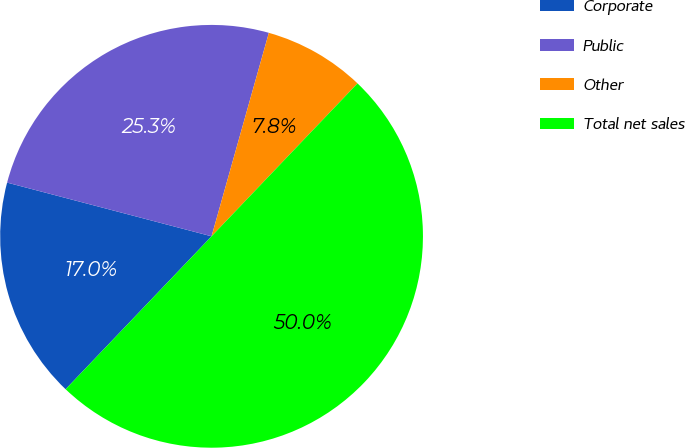Convert chart to OTSL. <chart><loc_0><loc_0><loc_500><loc_500><pie_chart><fcel>Corporate<fcel>Public<fcel>Other<fcel>Total net sales<nl><fcel>16.96%<fcel>25.28%<fcel>7.76%<fcel>50.0%<nl></chart> 